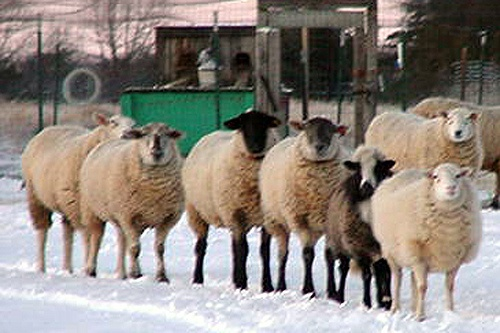Describe the objects in this image and their specific colors. I can see sheep in gray, darkgray, and tan tones, sheep in gray, black, and tan tones, sheep in gray and tan tones, sheep in gray, black, and tan tones, and sheep in gray, tan, and darkgray tones in this image. 